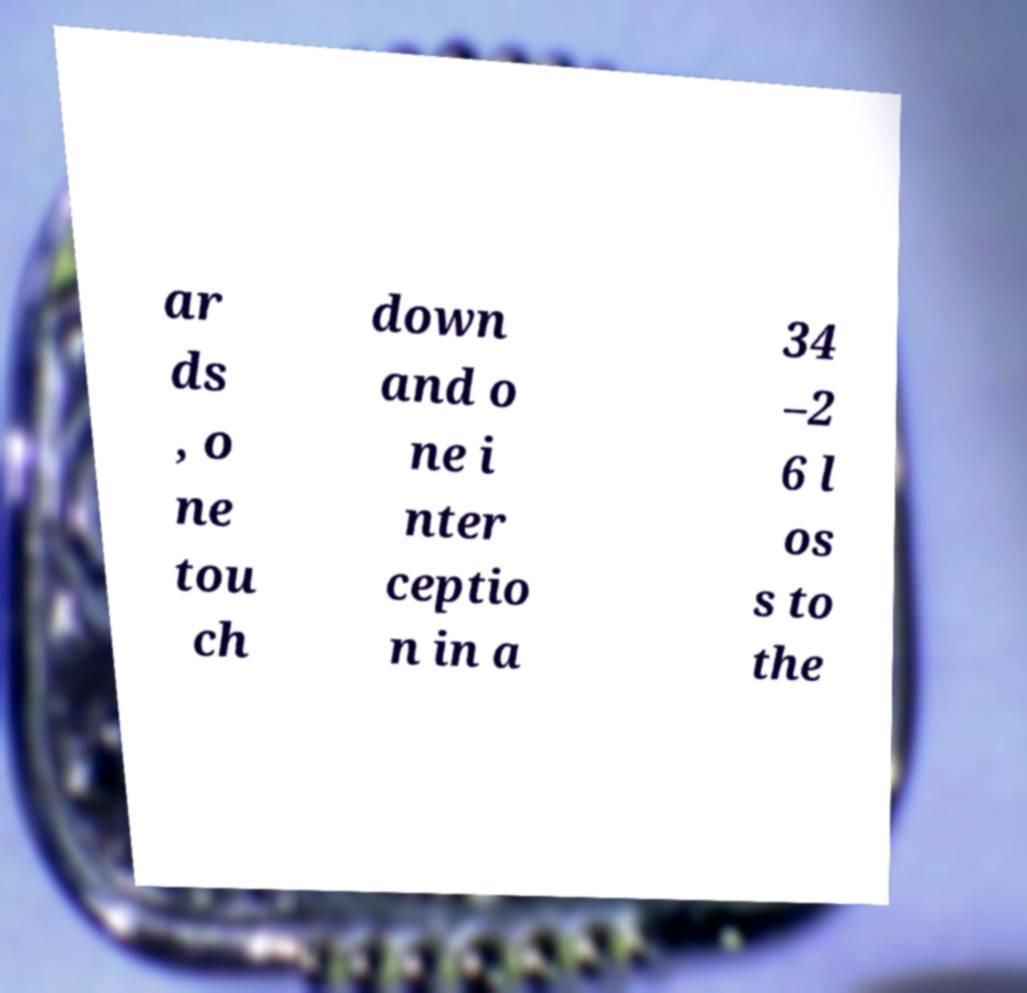Please identify and transcribe the text found in this image. ar ds , o ne tou ch down and o ne i nter ceptio n in a 34 –2 6 l os s to the 